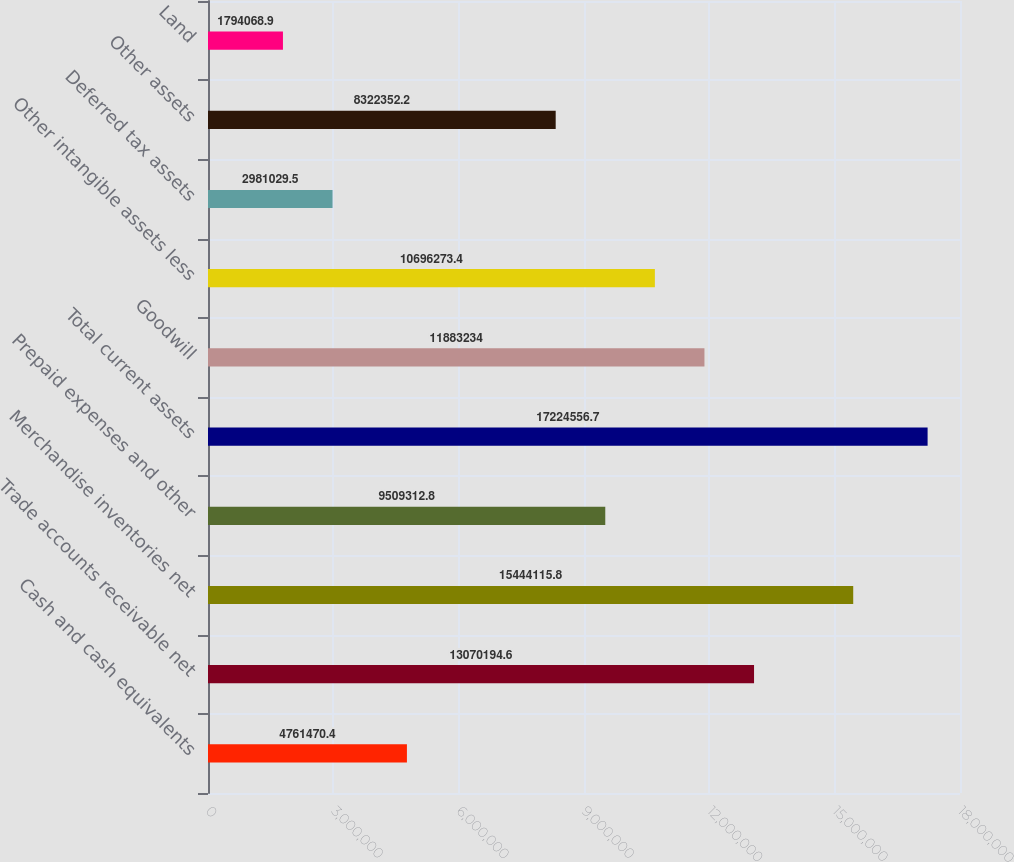<chart> <loc_0><loc_0><loc_500><loc_500><bar_chart><fcel>Cash and cash equivalents<fcel>Trade accounts receivable net<fcel>Merchandise inventories net<fcel>Prepaid expenses and other<fcel>Total current assets<fcel>Goodwill<fcel>Other intangible assets less<fcel>Deferred tax assets<fcel>Other assets<fcel>Land<nl><fcel>4.76147e+06<fcel>1.30702e+07<fcel>1.54441e+07<fcel>9.50931e+06<fcel>1.72246e+07<fcel>1.18832e+07<fcel>1.06963e+07<fcel>2.98103e+06<fcel>8.32235e+06<fcel>1.79407e+06<nl></chart> 